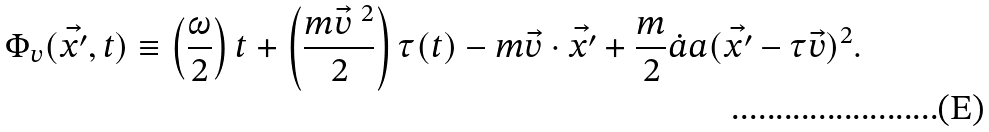Convert formula to latex. <formula><loc_0><loc_0><loc_500><loc_500>\Phi _ { v } ( \vec { x ^ { \prime } } , t ) \equiv \left ( \frac { \omega } { 2 } \right ) t + \left ( \frac { m { \vec { v } } ^ { \ 2 } } { 2 } \right ) \tau ( t ) - m \vec { v } \cdot \vec { x ^ { \prime } } + \frac { m } { 2 } { \dot { a } } a ( \vec { x ^ { \prime } } - \tau \vec { v } ) ^ { 2 } .</formula> 